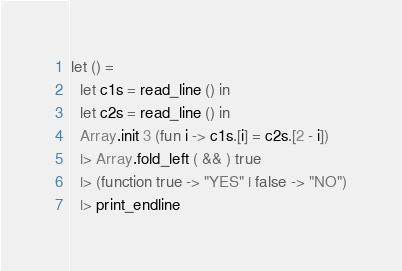<code> <loc_0><loc_0><loc_500><loc_500><_OCaml_>let () =
  let c1s = read_line () in
  let c2s = read_line () in
  Array.init 3 (fun i -> c1s.[i] = c2s.[2 - i])
  |> Array.fold_left ( && ) true
  |> (function true -> "YES" | false -> "NO")
  |> print_endline</code> 